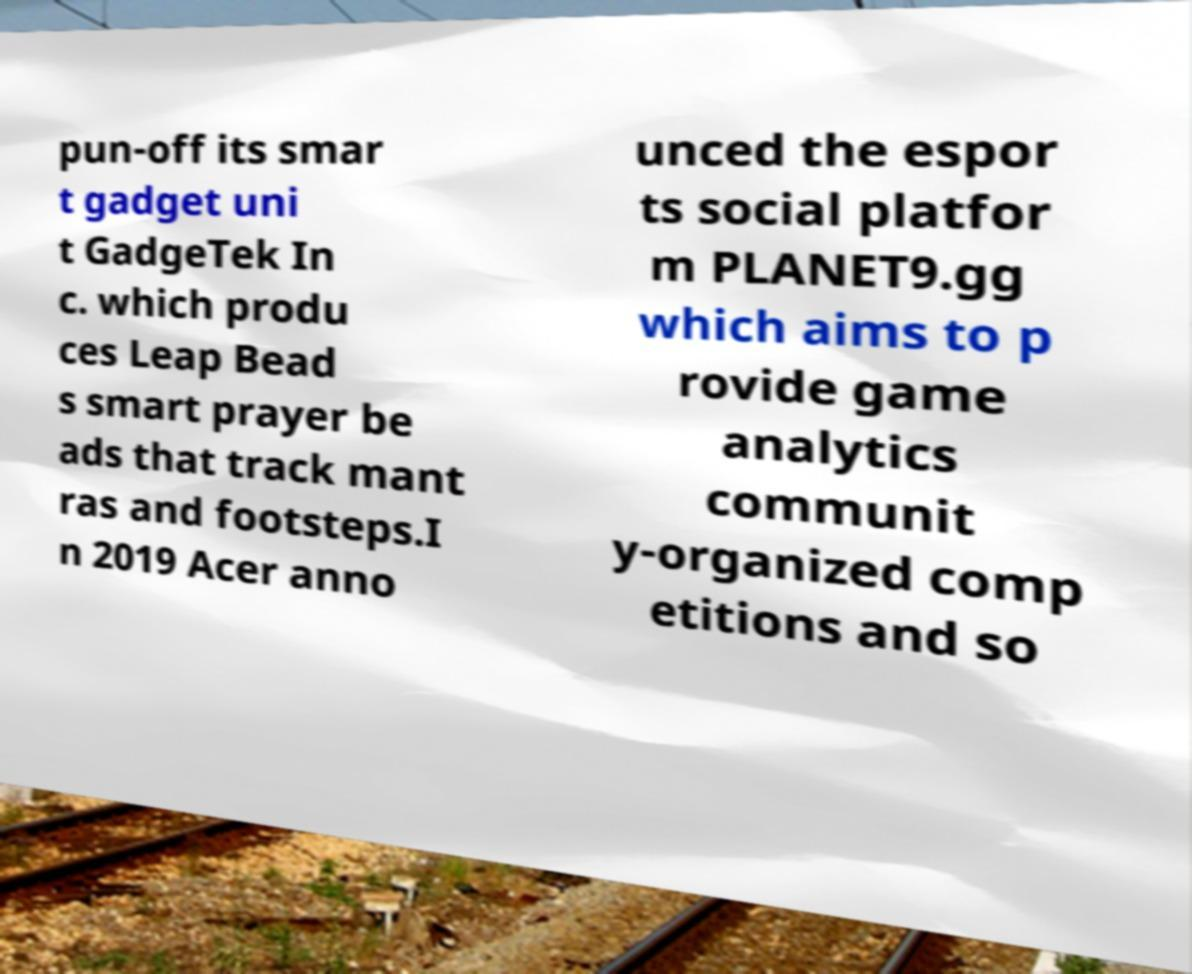Please identify and transcribe the text found in this image. pun-off its smar t gadget uni t GadgeTek In c. which produ ces Leap Bead s smart prayer be ads that track mant ras and footsteps.I n 2019 Acer anno unced the espor ts social platfor m PLANET9.gg which aims to p rovide game analytics communit y-organized comp etitions and so 